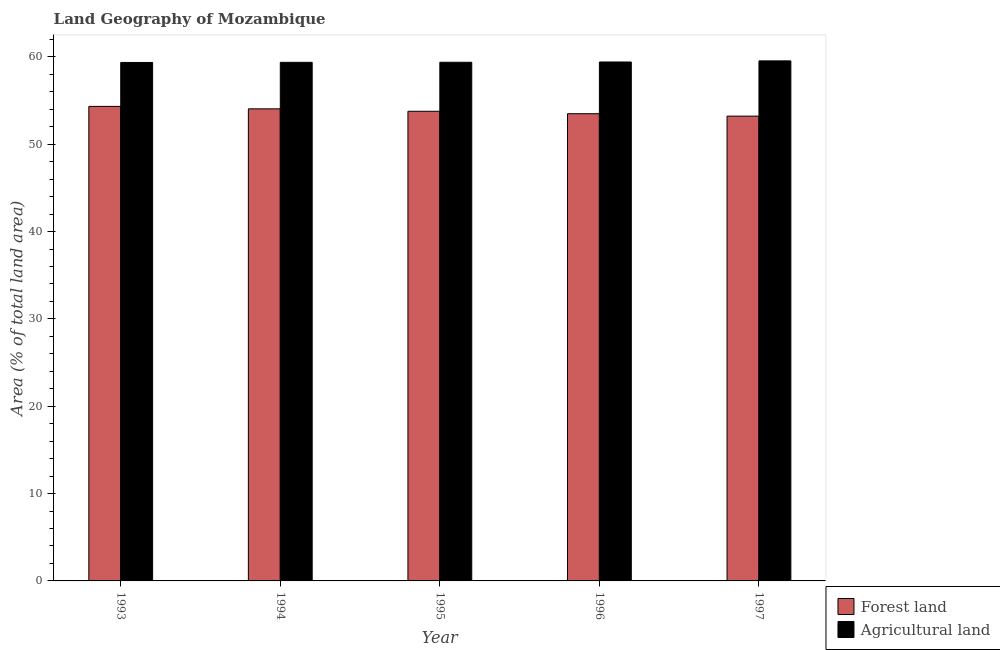How many groups of bars are there?
Provide a succinct answer. 5. Are the number of bars per tick equal to the number of legend labels?
Make the answer very short. Yes. Are the number of bars on each tick of the X-axis equal?
Ensure brevity in your answer.  Yes. How many bars are there on the 2nd tick from the left?
Offer a terse response. 2. What is the label of the 2nd group of bars from the left?
Your answer should be compact. 1994. In how many cases, is the number of bars for a given year not equal to the number of legend labels?
Offer a terse response. 0. What is the percentage of land area under agriculture in 1996?
Provide a succinct answer. 59.41. Across all years, what is the maximum percentage of land area under forests?
Keep it short and to the point. 54.33. Across all years, what is the minimum percentage of land area under forests?
Provide a short and direct response. 53.21. In which year was the percentage of land area under forests maximum?
Your response must be concise. 1993. In which year was the percentage of land area under forests minimum?
Provide a succinct answer. 1997. What is the total percentage of land area under forests in the graph?
Offer a very short reply. 268.85. What is the difference between the percentage of land area under agriculture in 1994 and that in 1995?
Ensure brevity in your answer.  -0.01. What is the difference between the percentage of land area under agriculture in 1995 and the percentage of land area under forests in 1994?
Ensure brevity in your answer.  0.01. What is the average percentage of land area under agriculture per year?
Provide a short and direct response. 59.41. In how many years, is the percentage of land area under agriculture greater than 42 %?
Provide a succinct answer. 5. What is the ratio of the percentage of land area under forests in 1993 to that in 1997?
Offer a very short reply. 1.02. Is the percentage of land area under agriculture in 1996 less than that in 1997?
Give a very brief answer. Yes. Is the difference between the percentage of land area under agriculture in 1995 and 1997 greater than the difference between the percentage of land area under forests in 1995 and 1997?
Your response must be concise. No. What is the difference between the highest and the second highest percentage of land area under agriculture?
Provide a succinct answer. 0.13. What is the difference between the highest and the lowest percentage of land area under agriculture?
Keep it short and to the point. 0.18. Is the sum of the percentage of land area under agriculture in 1993 and 1997 greater than the maximum percentage of land area under forests across all years?
Give a very brief answer. Yes. What does the 2nd bar from the left in 1995 represents?
Make the answer very short. Agricultural land. What does the 2nd bar from the right in 1995 represents?
Give a very brief answer. Forest land. How many bars are there?
Keep it short and to the point. 10. Does the graph contain any zero values?
Your answer should be compact. No. How are the legend labels stacked?
Your response must be concise. Vertical. What is the title of the graph?
Offer a very short reply. Land Geography of Mozambique. What is the label or title of the Y-axis?
Ensure brevity in your answer.  Area (% of total land area). What is the Area (% of total land area) in Forest land in 1993?
Provide a succinct answer. 54.33. What is the Area (% of total land area) in Agricultural land in 1993?
Offer a very short reply. 59.36. What is the Area (% of total land area) of Forest land in 1994?
Your answer should be very brief. 54.05. What is the Area (% of total land area) in Agricultural land in 1994?
Make the answer very short. 59.37. What is the Area (% of total land area) in Forest land in 1995?
Keep it short and to the point. 53.77. What is the Area (% of total land area) of Agricultural land in 1995?
Provide a succinct answer. 59.38. What is the Area (% of total land area) of Forest land in 1996?
Offer a very short reply. 53.49. What is the Area (% of total land area) of Agricultural land in 1996?
Your answer should be compact. 59.41. What is the Area (% of total land area) in Forest land in 1997?
Ensure brevity in your answer.  53.21. What is the Area (% of total land area) in Agricultural land in 1997?
Your answer should be very brief. 59.54. Across all years, what is the maximum Area (% of total land area) in Forest land?
Make the answer very short. 54.33. Across all years, what is the maximum Area (% of total land area) in Agricultural land?
Offer a terse response. 59.54. Across all years, what is the minimum Area (% of total land area) of Forest land?
Provide a short and direct response. 53.21. Across all years, what is the minimum Area (% of total land area) of Agricultural land?
Provide a short and direct response. 59.36. What is the total Area (% of total land area) in Forest land in the graph?
Give a very brief answer. 268.85. What is the total Area (% of total land area) of Agricultural land in the graph?
Your response must be concise. 297.06. What is the difference between the Area (% of total land area) in Forest land in 1993 and that in 1994?
Ensure brevity in your answer.  0.28. What is the difference between the Area (% of total land area) of Agricultural land in 1993 and that in 1994?
Your answer should be very brief. -0.01. What is the difference between the Area (% of total land area) in Forest land in 1993 and that in 1995?
Provide a succinct answer. 0.56. What is the difference between the Area (% of total land area) of Agricultural land in 1993 and that in 1995?
Give a very brief answer. -0.02. What is the difference between the Area (% of total land area) of Forest land in 1993 and that in 1996?
Make the answer very short. 0.84. What is the difference between the Area (% of total land area) of Agricultural land in 1993 and that in 1996?
Your response must be concise. -0.05. What is the difference between the Area (% of total land area) in Forest land in 1993 and that in 1997?
Make the answer very short. 1.11. What is the difference between the Area (% of total land area) in Agricultural land in 1993 and that in 1997?
Ensure brevity in your answer.  -0.18. What is the difference between the Area (% of total land area) of Forest land in 1994 and that in 1995?
Provide a succinct answer. 0.28. What is the difference between the Area (% of total land area) in Agricultural land in 1994 and that in 1995?
Make the answer very short. -0.01. What is the difference between the Area (% of total land area) of Forest land in 1994 and that in 1996?
Make the answer very short. 0.56. What is the difference between the Area (% of total land area) of Agricultural land in 1994 and that in 1996?
Provide a succinct answer. -0.04. What is the difference between the Area (% of total land area) of Forest land in 1994 and that in 1997?
Provide a short and direct response. 0.84. What is the difference between the Area (% of total land area) in Agricultural land in 1994 and that in 1997?
Offer a very short reply. -0.17. What is the difference between the Area (% of total land area) of Forest land in 1995 and that in 1996?
Ensure brevity in your answer.  0.28. What is the difference between the Area (% of total land area) of Agricultural land in 1995 and that in 1996?
Offer a very short reply. -0.03. What is the difference between the Area (% of total land area) in Forest land in 1995 and that in 1997?
Your answer should be very brief. 0.56. What is the difference between the Area (% of total land area) in Agricultural land in 1995 and that in 1997?
Provide a short and direct response. -0.16. What is the difference between the Area (% of total land area) in Forest land in 1996 and that in 1997?
Make the answer very short. 0.28. What is the difference between the Area (% of total land area) of Agricultural land in 1996 and that in 1997?
Offer a terse response. -0.13. What is the difference between the Area (% of total land area) in Forest land in 1993 and the Area (% of total land area) in Agricultural land in 1994?
Make the answer very short. -5.04. What is the difference between the Area (% of total land area) of Forest land in 1993 and the Area (% of total land area) of Agricultural land in 1995?
Offer a very short reply. -5.05. What is the difference between the Area (% of total land area) in Forest land in 1993 and the Area (% of total land area) in Agricultural land in 1996?
Provide a succinct answer. -5.09. What is the difference between the Area (% of total land area) of Forest land in 1993 and the Area (% of total land area) of Agricultural land in 1997?
Your answer should be very brief. -5.21. What is the difference between the Area (% of total land area) in Forest land in 1994 and the Area (% of total land area) in Agricultural land in 1995?
Provide a succinct answer. -5.33. What is the difference between the Area (% of total land area) of Forest land in 1994 and the Area (% of total land area) of Agricultural land in 1996?
Your answer should be compact. -5.36. What is the difference between the Area (% of total land area) of Forest land in 1994 and the Area (% of total land area) of Agricultural land in 1997?
Your answer should be very brief. -5.49. What is the difference between the Area (% of total land area) of Forest land in 1995 and the Area (% of total land area) of Agricultural land in 1996?
Offer a terse response. -5.64. What is the difference between the Area (% of total land area) in Forest land in 1995 and the Area (% of total land area) in Agricultural land in 1997?
Make the answer very short. -5.77. What is the difference between the Area (% of total land area) of Forest land in 1996 and the Area (% of total land area) of Agricultural land in 1997?
Keep it short and to the point. -6.05. What is the average Area (% of total land area) of Forest land per year?
Offer a very short reply. 53.77. What is the average Area (% of total land area) of Agricultural land per year?
Your answer should be compact. 59.41. In the year 1993, what is the difference between the Area (% of total land area) in Forest land and Area (% of total land area) in Agricultural land?
Ensure brevity in your answer.  -5.03. In the year 1994, what is the difference between the Area (% of total land area) in Forest land and Area (% of total land area) in Agricultural land?
Keep it short and to the point. -5.32. In the year 1995, what is the difference between the Area (% of total land area) in Forest land and Area (% of total land area) in Agricultural land?
Offer a terse response. -5.61. In the year 1996, what is the difference between the Area (% of total land area) of Forest land and Area (% of total land area) of Agricultural land?
Your answer should be compact. -5.92. In the year 1997, what is the difference between the Area (% of total land area) of Forest land and Area (% of total land area) of Agricultural land?
Offer a very short reply. -6.33. What is the ratio of the Area (% of total land area) in Forest land in 1993 to that in 1995?
Ensure brevity in your answer.  1.01. What is the ratio of the Area (% of total land area) in Agricultural land in 1993 to that in 1995?
Keep it short and to the point. 1. What is the ratio of the Area (% of total land area) of Forest land in 1993 to that in 1996?
Ensure brevity in your answer.  1.02. What is the ratio of the Area (% of total land area) of Agricultural land in 1993 to that in 1996?
Your answer should be very brief. 1. What is the ratio of the Area (% of total land area) in Forest land in 1993 to that in 1997?
Provide a succinct answer. 1.02. What is the ratio of the Area (% of total land area) in Forest land in 1994 to that in 1995?
Give a very brief answer. 1.01. What is the ratio of the Area (% of total land area) of Forest land in 1994 to that in 1996?
Offer a very short reply. 1.01. What is the ratio of the Area (% of total land area) in Agricultural land in 1994 to that in 1996?
Offer a very short reply. 1. What is the ratio of the Area (% of total land area) of Forest land in 1994 to that in 1997?
Offer a terse response. 1.02. What is the ratio of the Area (% of total land area) in Forest land in 1995 to that in 1996?
Keep it short and to the point. 1.01. What is the ratio of the Area (% of total land area) of Agricultural land in 1995 to that in 1996?
Make the answer very short. 1. What is the ratio of the Area (% of total land area) in Forest land in 1995 to that in 1997?
Provide a succinct answer. 1.01. What is the ratio of the Area (% of total land area) in Agricultural land in 1995 to that in 1997?
Ensure brevity in your answer.  1. What is the ratio of the Area (% of total land area) of Agricultural land in 1996 to that in 1997?
Your answer should be very brief. 1. What is the difference between the highest and the second highest Area (% of total land area) in Forest land?
Provide a succinct answer. 0.28. What is the difference between the highest and the second highest Area (% of total land area) in Agricultural land?
Offer a terse response. 0.13. What is the difference between the highest and the lowest Area (% of total land area) in Forest land?
Your response must be concise. 1.11. What is the difference between the highest and the lowest Area (% of total land area) in Agricultural land?
Your answer should be very brief. 0.18. 